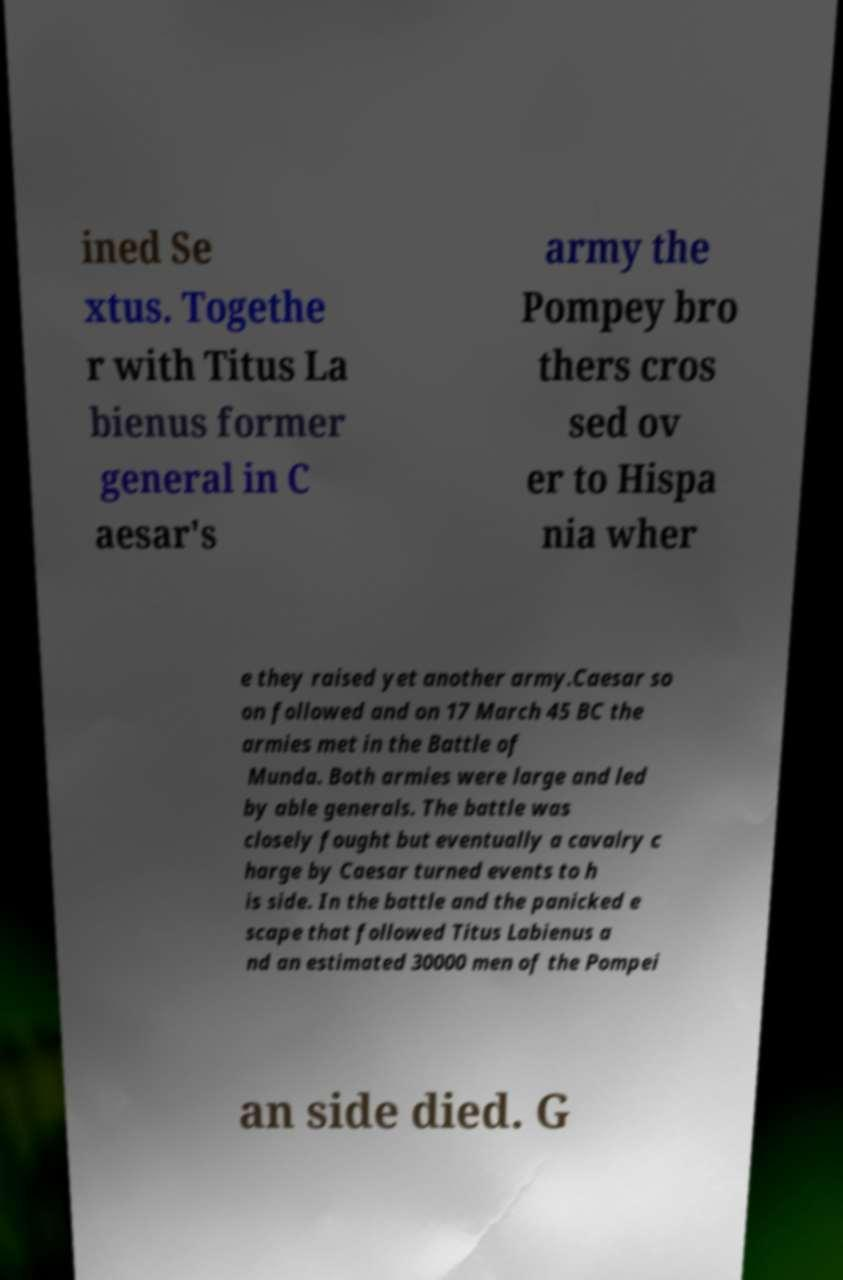Please identify and transcribe the text found in this image. ined Se xtus. Togethe r with Titus La bienus former general in C aesar's army the Pompey bro thers cros sed ov er to Hispa nia wher e they raised yet another army.Caesar so on followed and on 17 March 45 BC the armies met in the Battle of Munda. Both armies were large and led by able generals. The battle was closely fought but eventually a cavalry c harge by Caesar turned events to h is side. In the battle and the panicked e scape that followed Titus Labienus a nd an estimated 30000 men of the Pompei an side died. G 